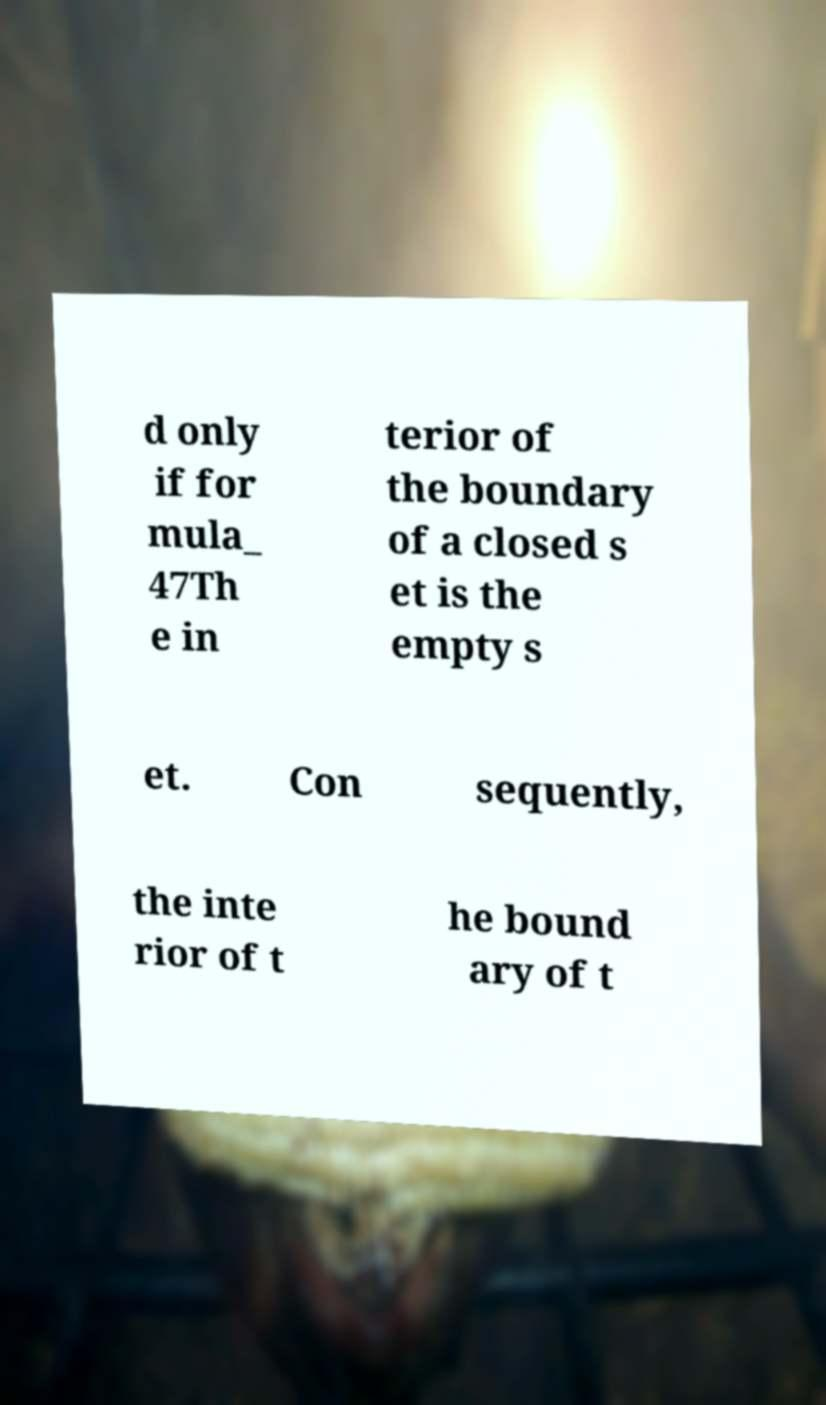There's text embedded in this image that I need extracted. Can you transcribe it verbatim? d only if for mula_ 47Th e in terior of the boundary of a closed s et is the empty s et. Con sequently, the inte rior of t he bound ary of t 